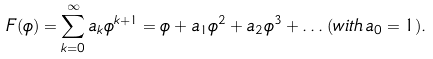<formula> <loc_0><loc_0><loc_500><loc_500>F ( \phi ) = \sum _ { k = 0 } ^ { \infty } a _ { k } \phi ^ { k + 1 } = \phi + a _ { 1 } \phi ^ { 2 } + a _ { 2 } \phi ^ { 3 } + \dots ( w i t h \, a _ { 0 } = 1 ) .</formula> 